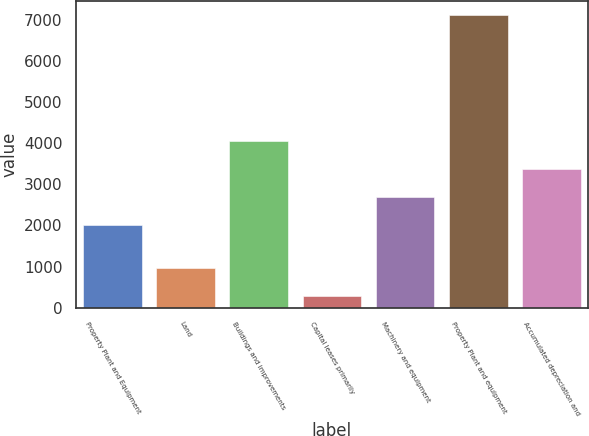Convert chart. <chart><loc_0><loc_0><loc_500><loc_500><bar_chart><fcel>Property Plant and Equipment<fcel>Land<fcel>Buildings and improvements<fcel>Capital leases primarily<fcel>Machinery and equipment<fcel>Property Plant and equipment<fcel>Accumulated depreciation and<nl><fcel>2010<fcel>956.9<fcel>4058.7<fcel>274<fcel>2692.9<fcel>7103<fcel>3375.8<nl></chart> 